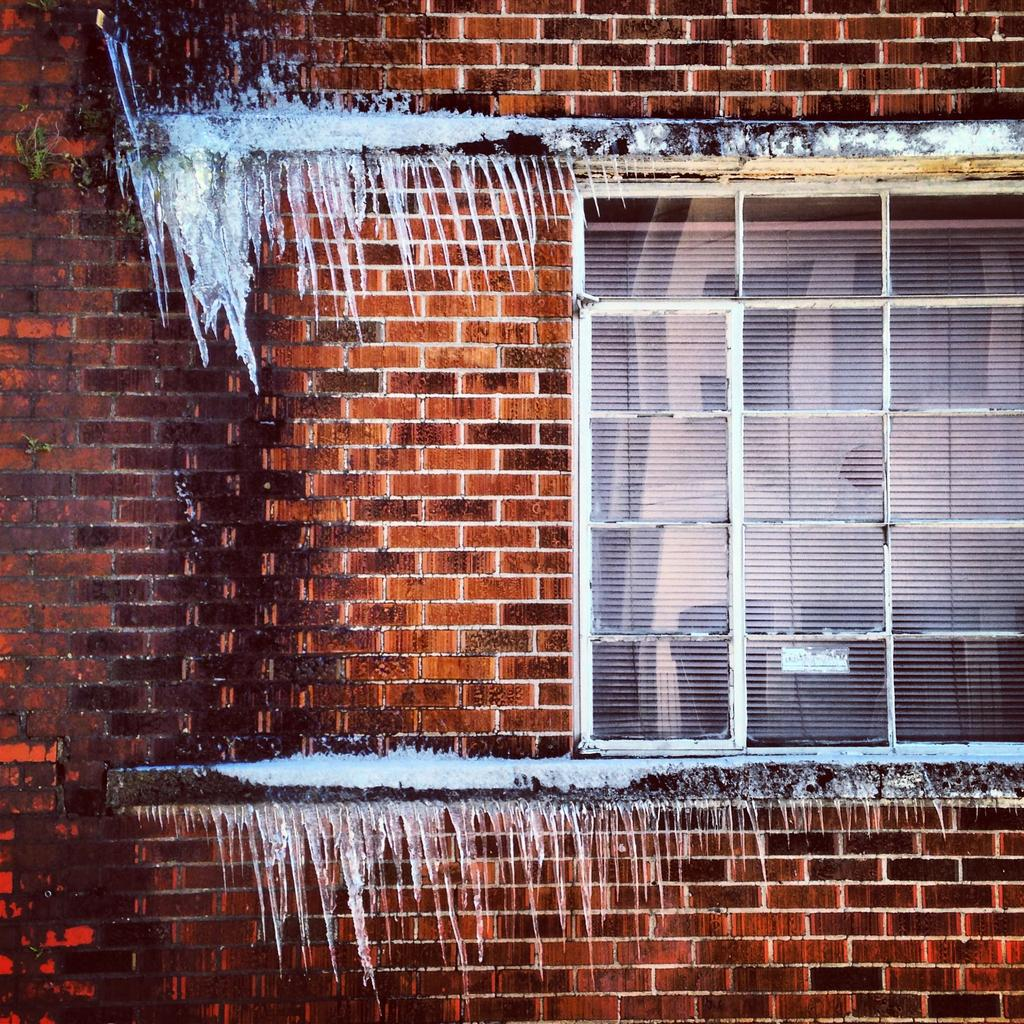What can be seen in the image that allows light to enter the room? There is a window in the image that allows light to enter the room. What is the material and color of the wall in the image? The wall in the image is made up of brown colored bricks. What is the frozen form of water visible in the image? There is ice visible in the image. What type of island can be seen in the image? There is no island present in the image. How many pickles are visible on the wall in the image? There are no pickles present in the image. 